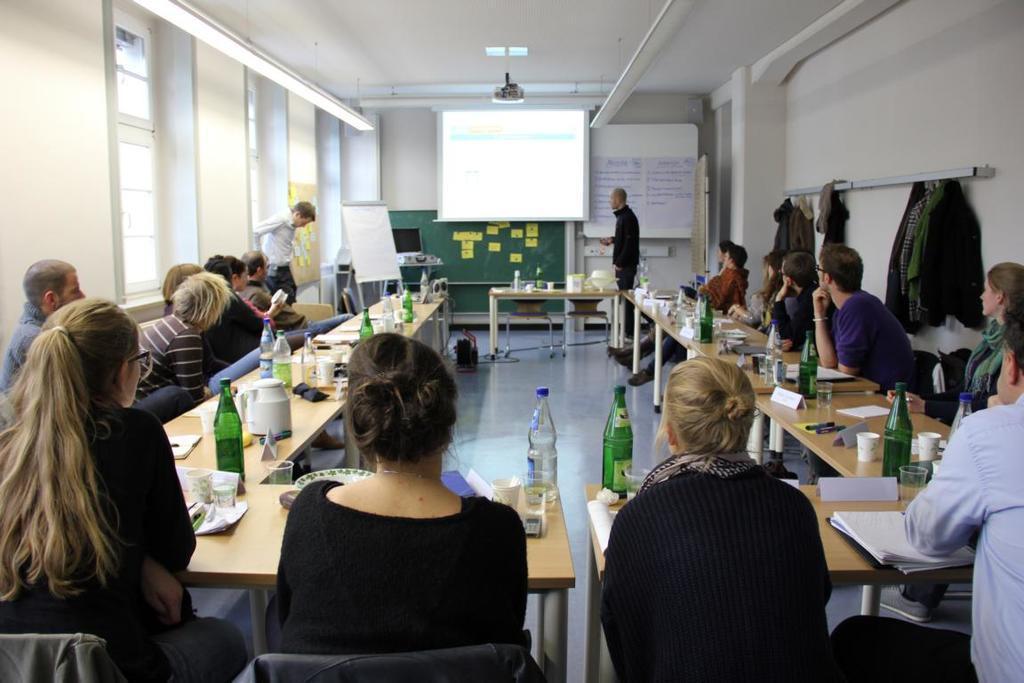Can you describe this image briefly? This image is taken indoors. At the top of the image there is a ceiling. In the background there is a wall. There are two boards with text on them and there is a projector screen. There is another board. There is a table with a few things on it and a man is standing on the floor. On the left side of the image there is a wall with a few windows. A few people are siting on the chairs and a man is standing on the floor. On the right side of the image there is a wall with hangers. A few people are siting on the chairs. In the middle of the image there are two tables with many things on them and two women are sitting on the chairs. 